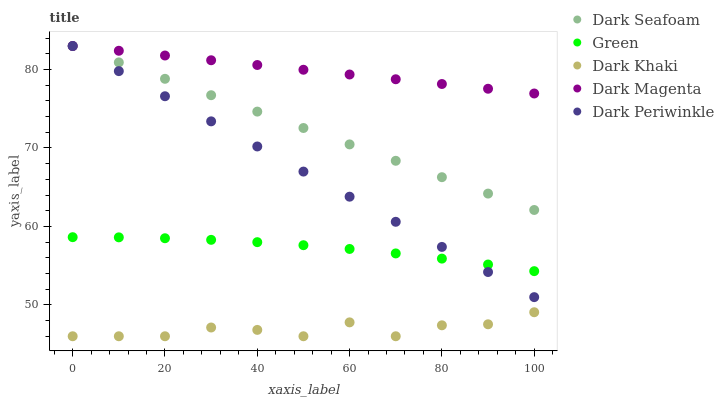Does Dark Khaki have the minimum area under the curve?
Answer yes or no. Yes. Does Dark Magenta have the maximum area under the curve?
Answer yes or no. Yes. Does Dark Seafoam have the minimum area under the curve?
Answer yes or no. No. Does Dark Seafoam have the maximum area under the curve?
Answer yes or no. No. Is Dark Seafoam the smoothest?
Answer yes or no. Yes. Is Dark Khaki the roughest?
Answer yes or no. Yes. Is Green the smoothest?
Answer yes or no. No. Is Green the roughest?
Answer yes or no. No. Does Dark Khaki have the lowest value?
Answer yes or no. Yes. Does Dark Seafoam have the lowest value?
Answer yes or no. No. Does Dark Periwinkle have the highest value?
Answer yes or no. Yes. Does Green have the highest value?
Answer yes or no. No. Is Dark Khaki less than Green?
Answer yes or no. Yes. Is Dark Magenta greater than Dark Khaki?
Answer yes or no. Yes. Does Dark Seafoam intersect Dark Magenta?
Answer yes or no. Yes. Is Dark Seafoam less than Dark Magenta?
Answer yes or no. No. Is Dark Seafoam greater than Dark Magenta?
Answer yes or no. No. Does Dark Khaki intersect Green?
Answer yes or no. No. 